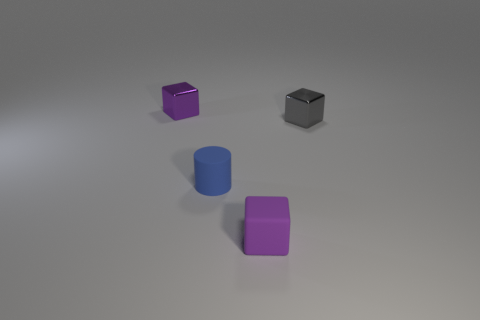Add 3 objects. How many objects exist? 7 Subtract all cylinders. How many objects are left? 3 Subtract 0 brown cylinders. How many objects are left? 4 Subtract all tiny brown metallic objects. Subtract all gray things. How many objects are left? 3 Add 4 purple metal things. How many purple metal things are left? 5 Add 4 large blue cylinders. How many large blue cylinders exist? 4 